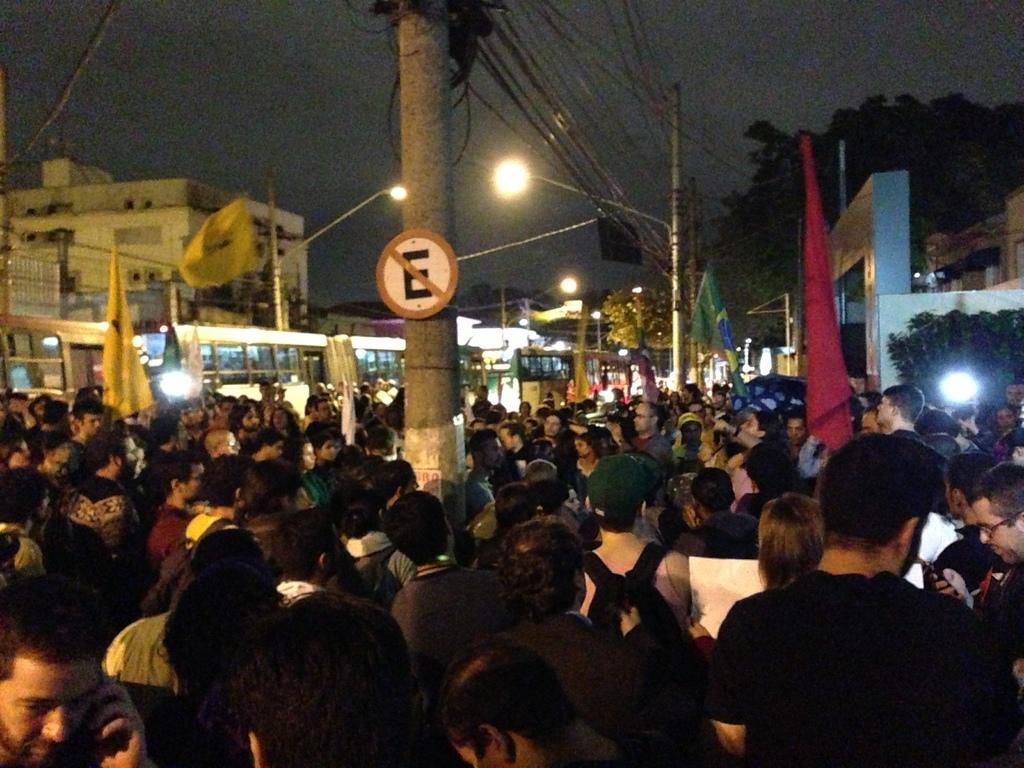How would you summarize this image in a sentence or two? In this picture there are people in the center of the image and there are buildings and trees on the right and left side of the image, there is a pole in the center of the image , there are buses on the left side of the image. 